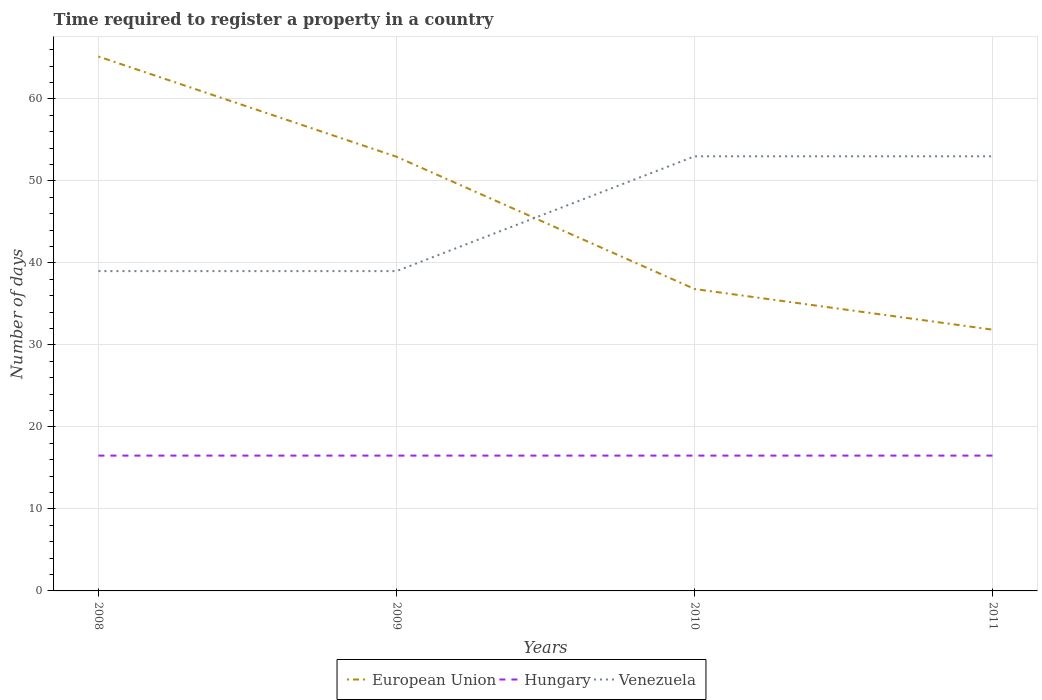How many different coloured lines are there?
Your response must be concise. 3. Across all years, what is the maximum number of days required to register a property in Hungary?
Offer a very short reply. 16.5. In which year was the number of days required to register a property in European Union maximum?
Provide a succinct answer. 2011. What is the total number of days required to register a property in European Union in the graph?
Offer a very short reply. 12.22. What is the difference between the highest and the second highest number of days required to register a property in Venezuela?
Keep it short and to the point. 14. How many lines are there?
Provide a short and direct response. 3. Does the graph contain grids?
Keep it short and to the point. Yes. Where does the legend appear in the graph?
Your response must be concise. Bottom center. How are the legend labels stacked?
Give a very brief answer. Horizontal. What is the title of the graph?
Your answer should be compact. Time required to register a property in a country. Does "Gambia, The" appear as one of the legend labels in the graph?
Your answer should be very brief. No. What is the label or title of the Y-axis?
Ensure brevity in your answer.  Number of days. What is the Number of days in European Union in 2008?
Your response must be concise. 65.17. What is the Number of days in European Union in 2009?
Offer a terse response. 52.94. What is the Number of days in Hungary in 2009?
Offer a terse response. 16.5. What is the Number of days in Venezuela in 2009?
Ensure brevity in your answer.  39. What is the Number of days of European Union in 2010?
Provide a succinct answer. 36.81. What is the Number of days in Venezuela in 2010?
Provide a succinct answer. 53. What is the Number of days in European Union in 2011?
Ensure brevity in your answer.  31.86. What is the Number of days in Venezuela in 2011?
Your response must be concise. 53. Across all years, what is the maximum Number of days in European Union?
Offer a very short reply. 65.17. Across all years, what is the maximum Number of days of Hungary?
Provide a short and direct response. 16.5. Across all years, what is the maximum Number of days of Venezuela?
Make the answer very short. 53. Across all years, what is the minimum Number of days of European Union?
Your answer should be compact. 31.86. Across all years, what is the minimum Number of days of Hungary?
Offer a very short reply. 16.5. What is the total Number of days of European Union in the graph?
Ensure brevity in your answer.  186.78. What is the total Number of days in Venezuela in the graph?
Ensure brevity in your answer.  184. What is the difference between the Number of days in European Union in 2008 and that in 2009?
Give a very brief answer. 12.22. What is the difference between the Number of days of Venezuela in 2008 and that in 2009?
Your response must be concise. 0. What is the difference between the Number of days in European Union in 2008 and that in 2010?
Give a very brief answer. 28.35. What is the difference between the Number of days of Hungary in 2008 and that in 2010?
Your response must be concise. 0. What is the difference between the Number of days in Venezuela in 2008 and that in 2010?
Your answer should be compact. -14. What is the difference between the Number of days of European Union in 2008 and that in 2011?
Your response must be concise. 33.31. What is the difference between the Number of days of Hungary in 2008 and that in 2011?
Keep it short and to the point. 0. What is the difference between the Number of days in Venezuela in 2008 and that in 2011?
Give a very brief answer. -14. What is the difference between the Number of days in European Union in 2009 and that in 2010?
Make the answer very short. 16.13. What is the difference between the Number of days in European Union in 2009 and that in 2011?
Your response must be concise. 21.09. What is the difference between the Number of days in European Union in 2010 and that in 2011?
Ensure brevity in your answer.  4.96. What is the difference between the Number of days of European Union in 2008 and the Number of days of Hungary in 2009?
Provide a succinct answer. 48.67. What is the difference between the Number of days of European Union in 2008 and the Number of days of Venezuela in 2009?
Your answer should be compact. 26.17. What is the difference between the Number of days of Hungary in 2008 and the Number of days of Venezuela in 2009?
Make the answer very short. -22.5. What is the difference between the Number of days of European Union in 2008 and the Number of days of Hungary in 2010?
Give a very brief answer. 48.67. What is the difference between the Number of days of European Union in 2008 and the Number of days of Venezuela in 2010?
Your response must be concise. 12.17. What is the difference between the Number of days of Hungary in 2008 and the Number of days of Venezuela in 2010?
Keep it short and to the point. -36.5. What is the difference between the Number of days in European Union in 2008 and the Number of days in Hungary in 2011?
Keep it short and to the point. 48.67. What is the difference between the Number of days of European Union in 2008 and the Number of days of Venezuela in 2011?
Provide a short and direct response. 12.17. What is the difference between the Number of days in Hungary in 2008 and the Number of days in Venezuela in 2011?
Keep it short and to the point. -36.5. What is the difference between the Number of days in European Union in 2009 and the Number of days in Hungary in 2010?
Keep it short and to the point. 36.44. What is the difference between the Number of days in European Union in 2009 and the Number of days in Venezuela in 2010?
Your answer should be compact. -0.06. What is the difference between the Number of days in Hungary in 2009 and the Number of days in Venezuela in 2010?
Offer a very short reply. -36.5. What is the difference between the Number of days of European Union in 2009 and the Number of days of Hungary in 2011?
Your response must be concise. 36.44. What is the difference between the Number of days of European Union in 2009 and the Number of days of Venezuela in 2011?
Provide a succinct answer. -0.06. What is the difference between the Number of days in Hungary in 2009 and the Number of days in Venezuela in 2011?
Your answer should be compact. -36.5. What is the difference between the Number of days of European Union in 2010 and the Number of days of Hungary in 2011?
Give a very brief answer. 20.31. What is the difference between the Number of days in European Union in 2010 and the Number of days in Venezuela in 2011?
Your answer should be very brief. -16.19. What is the difference between the Number of days of Hungary in 2010 and the Number of days of Venezuela in 2011?
Give a very brief answer. -36.5. What is the average Number of days of European Union per year?
Provide a short and direct response. 46.7. What is the average Number of days of Venezuela per year?
Offer a very short reply. 46. In the year 2008, what is the difference between the Number of days in European Union and Number of days in Hungary?
Offer a terse response. 48.67. In the year 2008, what is the difference between the Number of days in European Union and Number of days in Venezuela?
Provide a short and direct response. 26.17. In the year 2008, what is the difference between the Number of days in Hungary and Number of days in Venezuela?
Offer a very short reply. -22.5. In the year 2009, what is the difference between the Number of days of European Union and Number of days of Hungary?
Your response must be concise. 36.44. In the year 2009, what is the difference between the Number of days in European Union and Number of days in Venezuela?
Provide a short and direct response. 13.94. In the year 2009, what is the difference between the Number of days in Hungary and Number of days in Venezuela?
Ensure brevity in your answer.  -22.5. In the year 2010, what is the difference between the Number of days of European Union and Number of days of Hungary?
Offer a very short reply. 20.31. In the year 2010, what is the difference between the Number of days in European Union and Number of days in Venezuela?
Offer a terse response. -16.19. In the year 2010, what is the difference between the Number of days of Hungary and Number of days of Venezuela?
Your answer should be very brief. -36.5. In the year 2011, what is the difference between the Number of days in European Union and Number of days in Hungary?
Offer a terse response. 15.36. In the year 2011, what is the difference between the Number of days of European Union and Number of days of Venezuela?
Your answer should be compact. -21.14. In the year 2011, what is the difference between the Number of days of Hungary and Number of days of Venezuela?
Ensure brevity in your answer.  -36.5. What is the ratio of the Number of days in European Union in 2008 to that in 2009?
Keep it short and to the point. 1.23. What is the ratio of the Number of days in European Union in 2008 to that in 2010?
Offer a terse response. 1.77. What is the ratio of the Number of days in Hungary in 2008 to that in 2010?
Offer a terse response. 1. What is the ratio of the Number of days of Venezuela in 2008 to that in 2010?
Provide a succinct answer. 0.74. What is the ratio of the Number of days of European Union in 2008 to that in 2011?
Your response must be concise. 2.05. What is the ratio of the Number of days of Venezuela in 2008 to that in 2011?
Your answer should be very brief. 0.74. What is the ratio of the Number of days of European Union in 2009 to that in 2010?
Your response must be concise. 1.44. What is the ratio of the Number of days of Venezuela in 2009 to that in 2010?
Ensure brevity in your answer.  0.74. What is the ratio of the Number of days of European Union in 2009 to that in 2011?
Make the answer very short. 1.66. What is the ratio of the Number of days of Venezuela in 2009 to that in 2011?
Give a very brief answer. 0.74. What is the ratio of the Number of days in European Union in 2010 to that in 2011?
Provide a short and direct response. 1.16. What is the ratio of the Number of days of Venezuela in 2010 to that in 2011?
Your answer should be compact. 1. What is the difference between the highest and the second highest Number of days in European Union?
Ensure brevity in your answer.  12.22. What is the difference between the highest and the second highest Number of days in Venezuela?
Your response must be concise. 0. What is the difference between the highest and the lowest Number of days in European Union?
Your response must be concise. 33.31. 